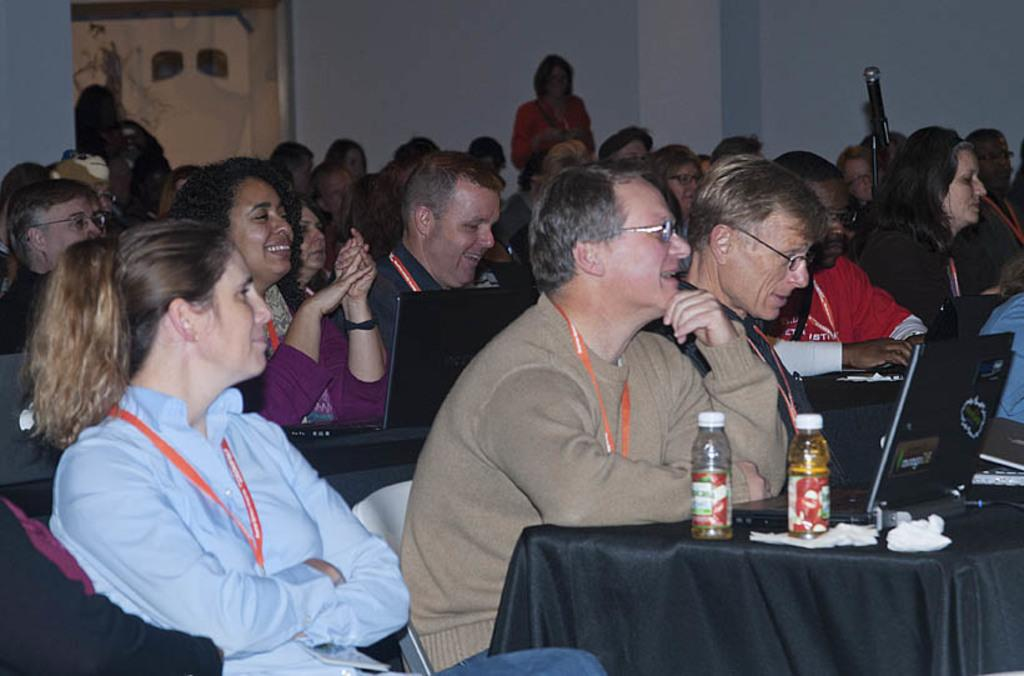What are the people in the image doing? The people in the image are sitting on chairs. What is the main piece of furniture in the image? There is a table in the image. What electronic device is on the table? A laptop is present on the table. What beverage is visible on the table? There is a juice bottle on the table. What type of polish is being applied to the calculator in the image? There is no calculator or polish present in the image. 